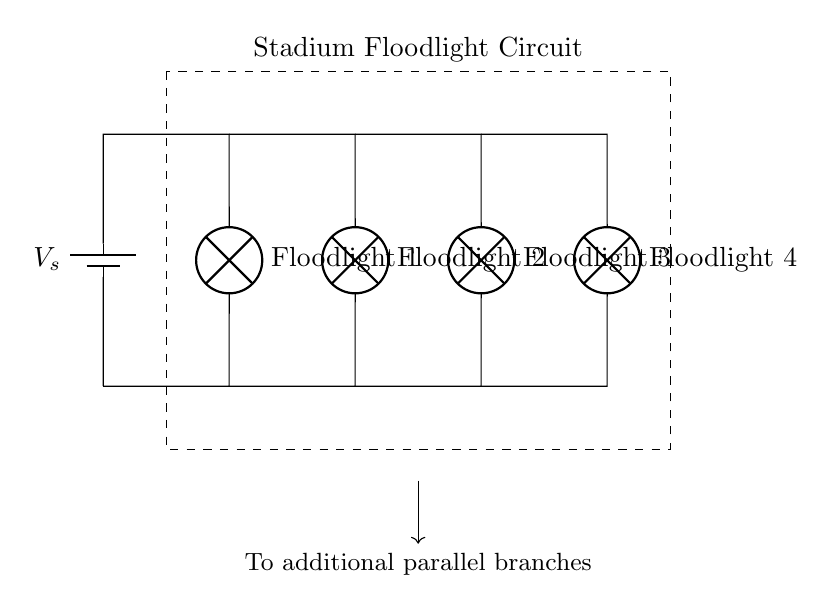What is the total number of floodlights in this circuit? The diagram shows four distinct floodlight symbols connected in parallel to the same power source. Each floodlight is labelled separately, making it easy to count them.
Answer: Four What type of circuit is shown in the diagram? The configuration of the floodlights being connected across the same two points indicates that the circuit is a parallel circuit. In a parallel circuit, each component shares the same voltage supply independently.
Answer: Parallel What is the significance of connecting floodlights in parallel? Connecting floodlights in parallel ensures that each floodlight receives the same voltage from the power supply, allowing for even illumination across the stadium. If one floodlight fails, the others will continue to operate.
Answer: Even illumination What component provides the voltage in this circuit? The circuit diagram features a battery symbol labelled as V sub s, indicating that the battery is the source providing the voltage necessary to light the floodlights.
Answer: Battery How does the failure of one floodlight affect the others in this circuit? In a parallel circuit, the failure of one floodlight does not affect the operation of the others, because each floodlight has its own direct connection to the voltage source. This design prevents disruption in illumination when one component fails.
Answer: No effect Which direction does the current flow in the floodlight circuit? Current flows from the positive terminal of the voltage source, through each of the floodlights, and returns to the negative terminal, completing the circuit. This flow direction can be inferred from the battery symbol, which indicates conventional current flow.
Answer: From positive to negative What is represented by the dashed rectangle in the circuit diagram? The dashed rectangle encloses the floodlight circuit and signifies the boundaries of this particular circuit setup, indicating that it could potentially connect with additional components outside the rectangle for expanded functionality.
Answer: Circuit boundary 